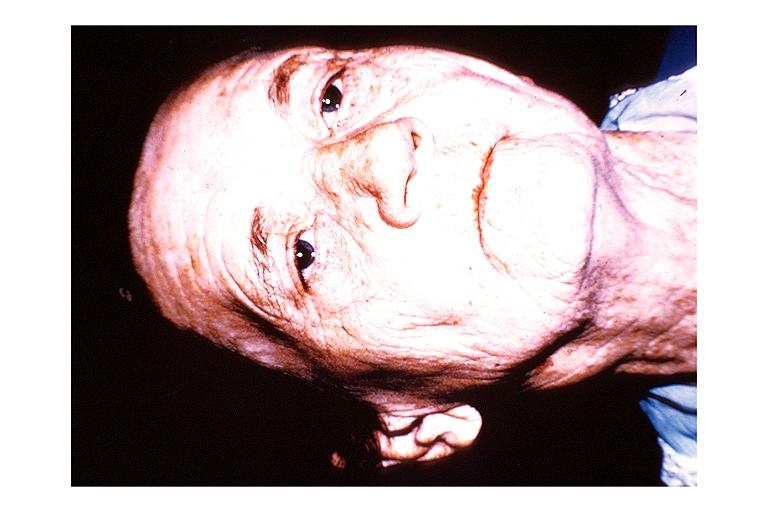s spina bifida present?
Answer the question using a single word or phrase. No 